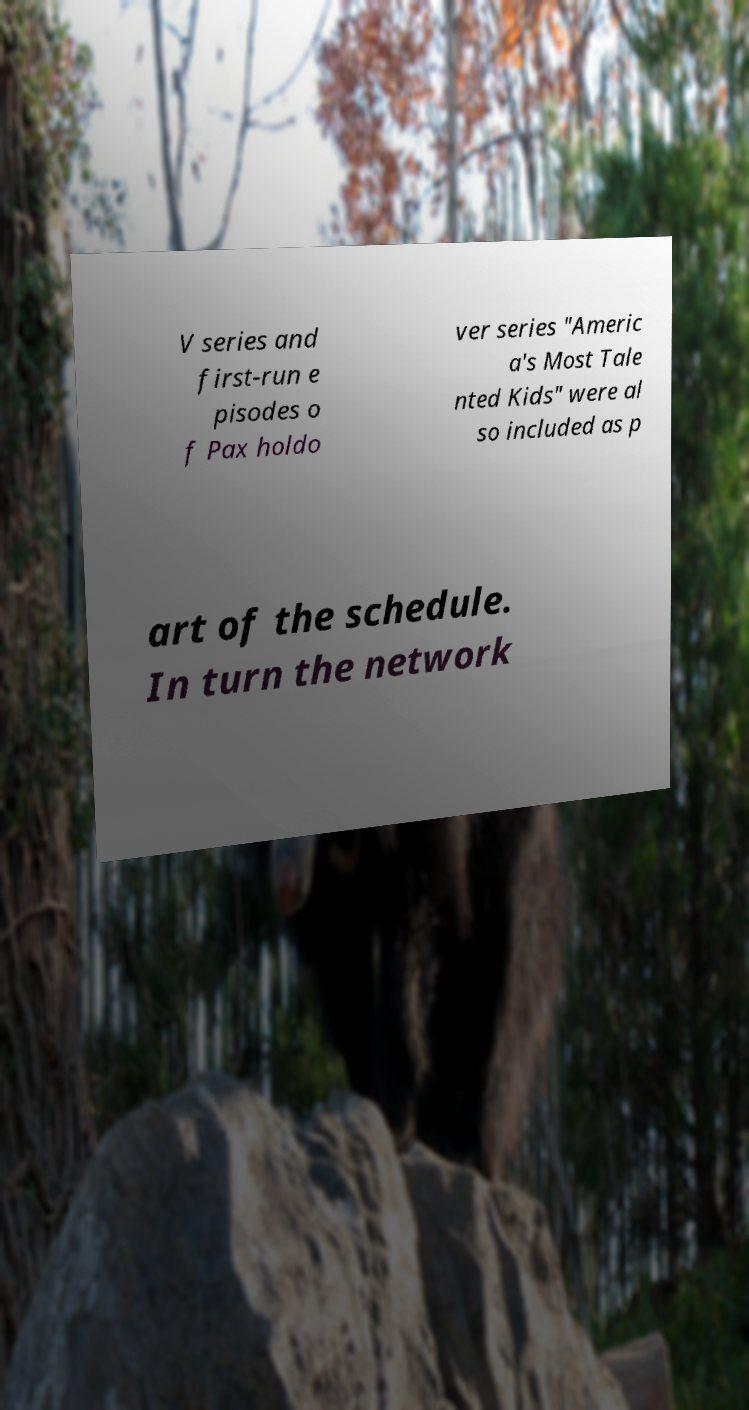There's text embedded in this image that I need extracted. Can you transcribe it verbatim? V series and first-run e pisodes o f Pax holdo ver series "Americ a's Most Tale nted Kids" were al so included as p art of the schedule. In turn the network 